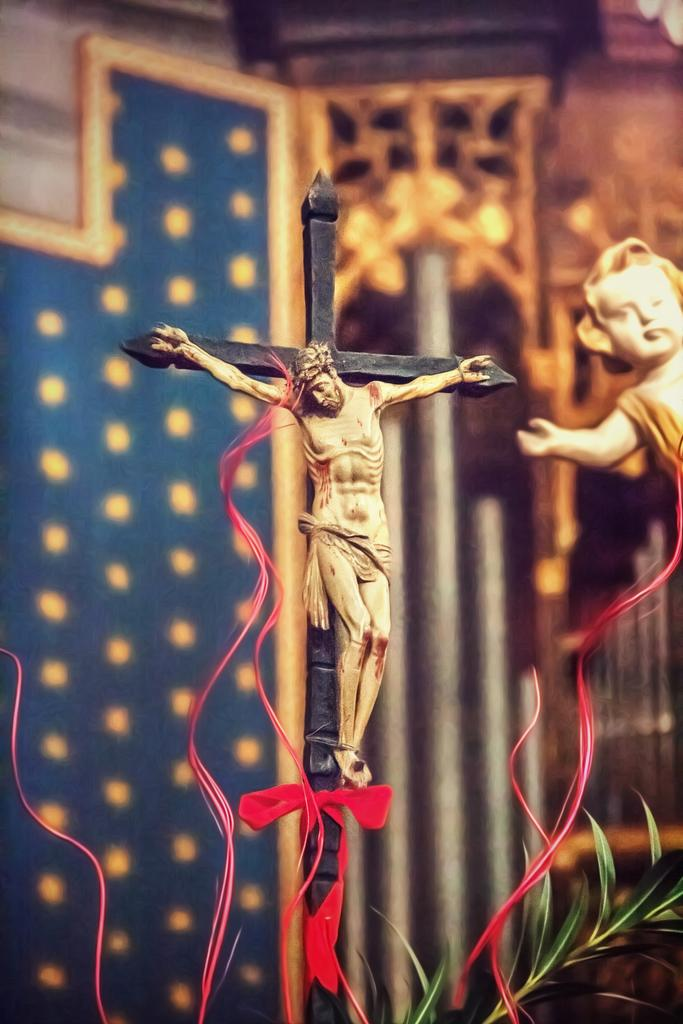What religious symbol is present in the image? There is a crucifix in the image. What type of living organism can be seen in the image? There is a plant in the image. What can be seen in the background of the image? There are lights and a wall in the background of the image. What type of furniture is present in the image? There is no furniture present in the image. What type of feast is being celebrated in the image? There is no feast depicted in the image. 